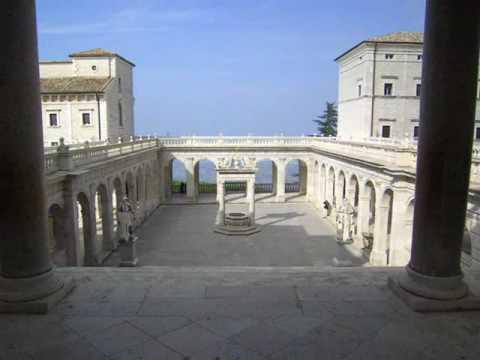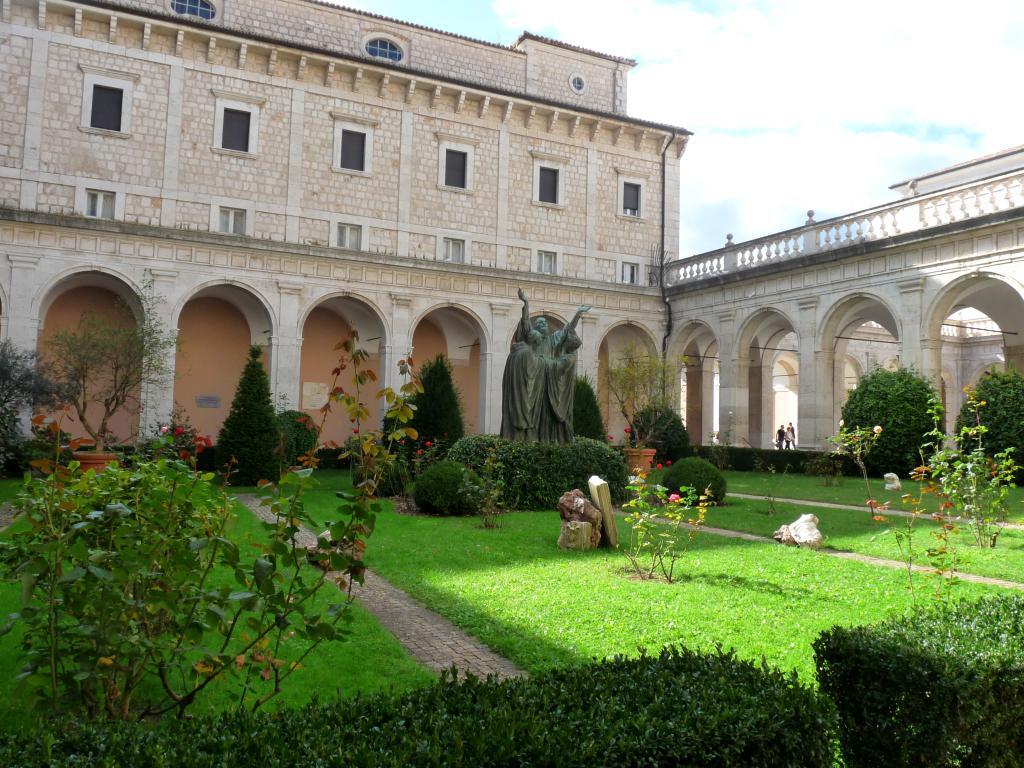The first image is the image on the left, the second image is the image on the right. For the images displayed, is the sentence "The building in the image on the left is surrounded by lush greenery." factually correct? Answer yes or no. No. The first image is the image on the left, the second image is the image on the right. Assess this claim about the two images: "An image shows a stone-floored courtyard surrounded by arches, with a view through the arches into an empty distance.". Correct or not? Answer yes or no. Yes. 